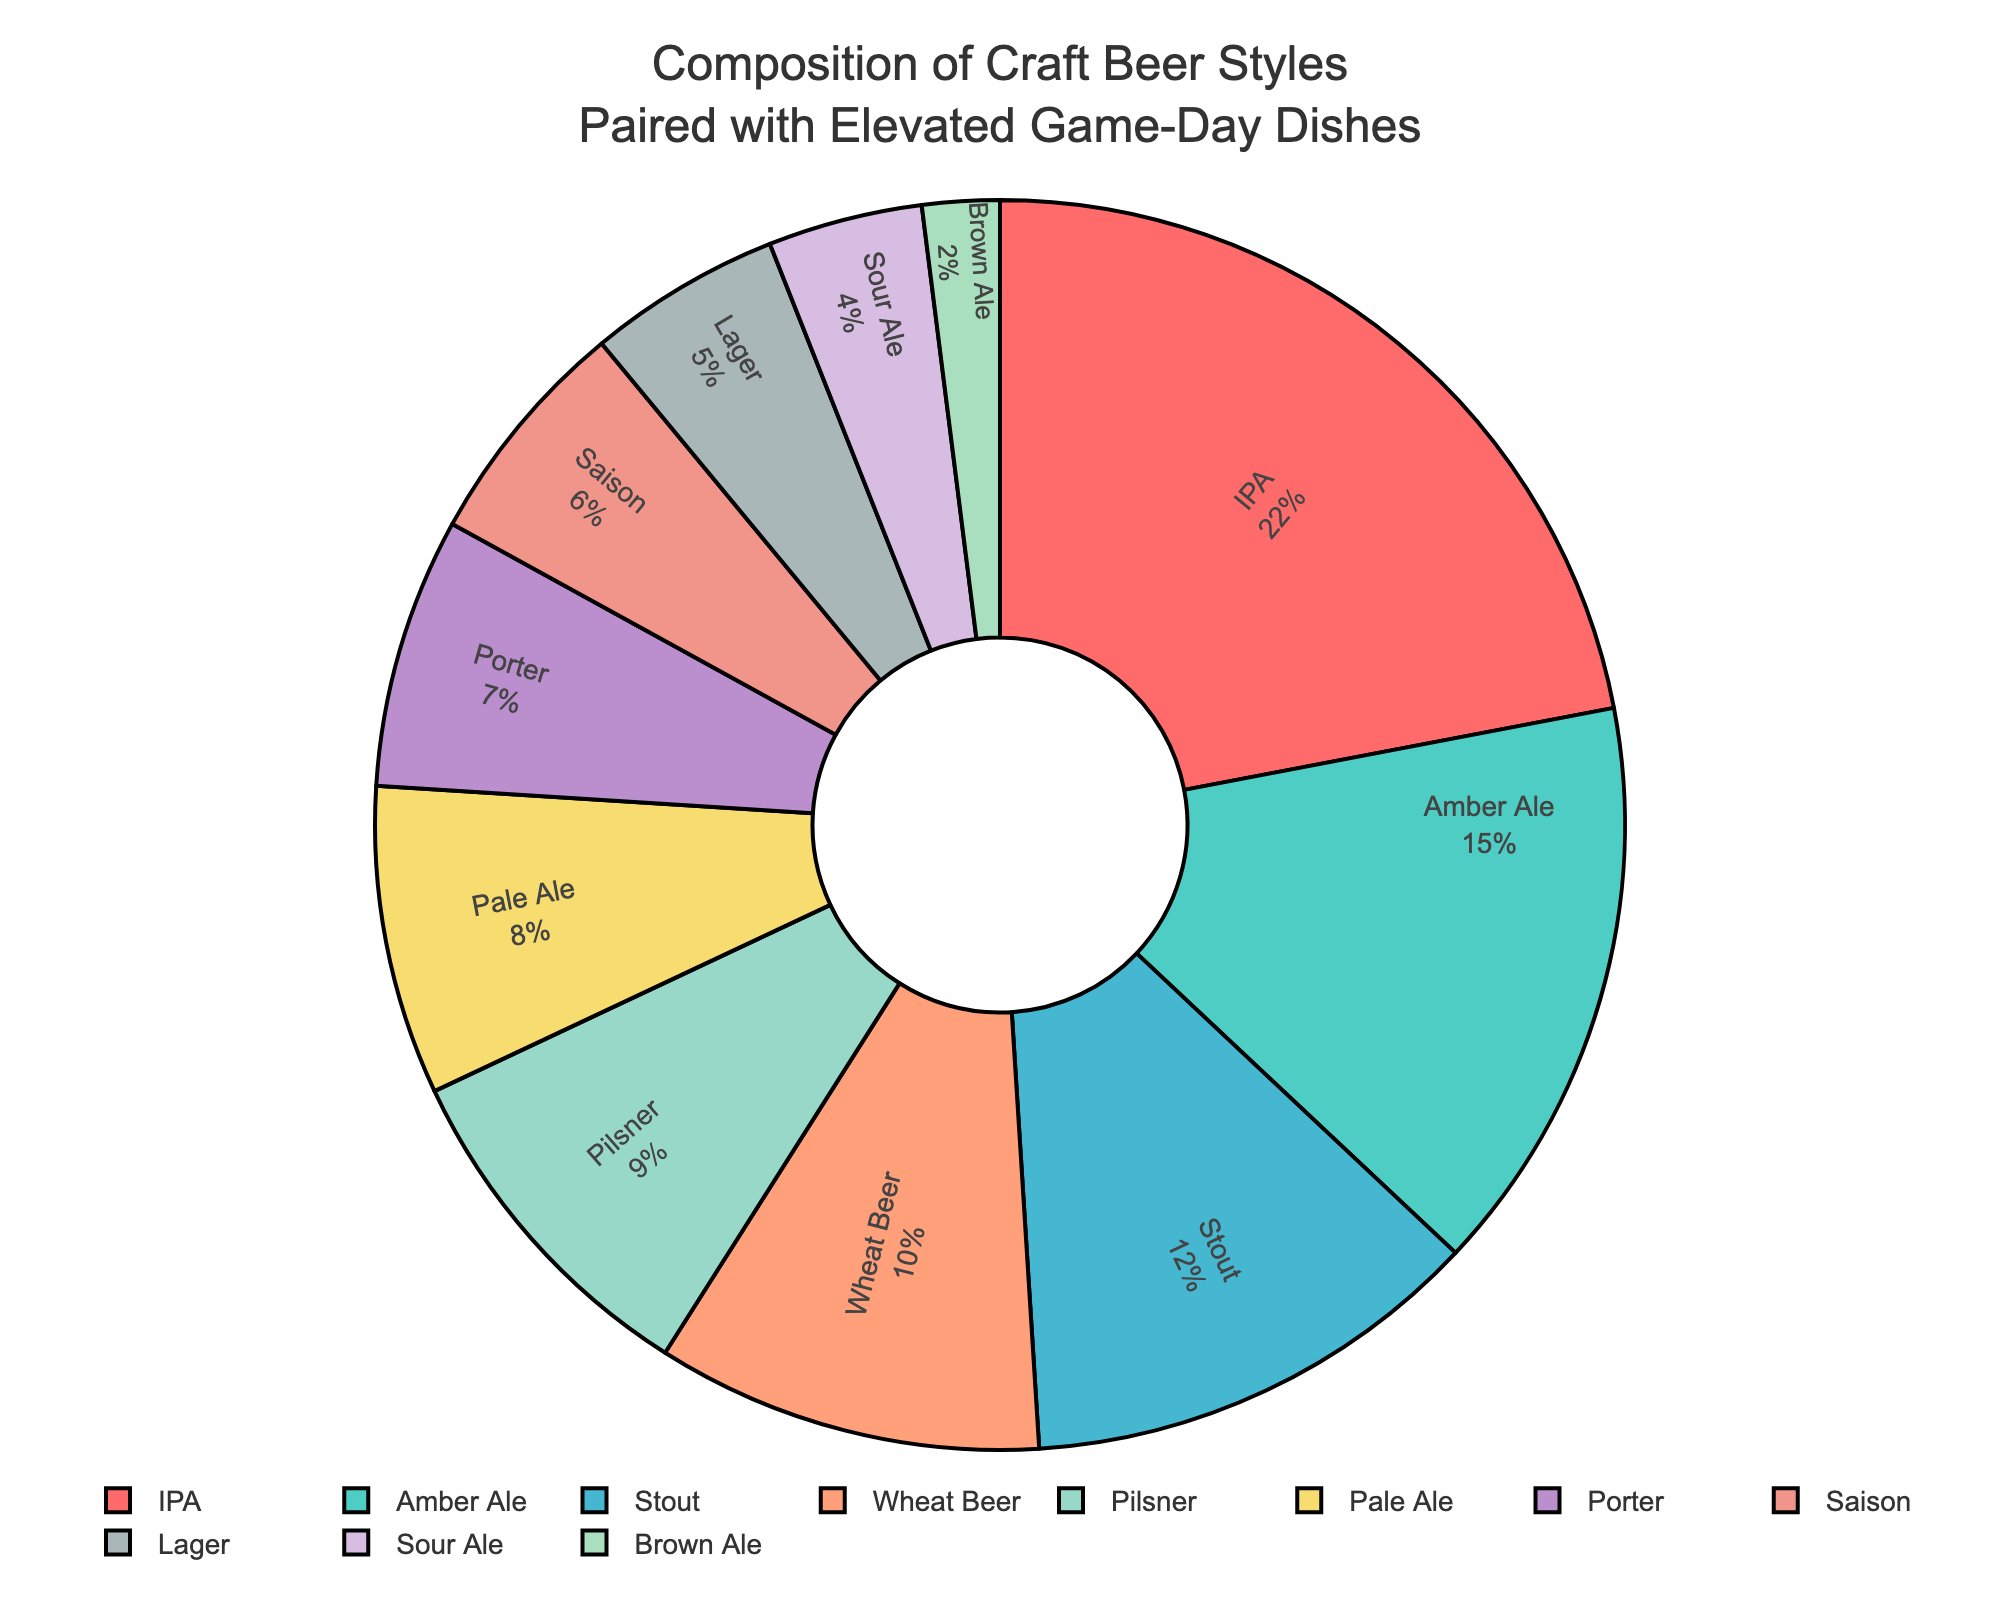Which beer style has the highest percentage? By observing the labels inside the pie segments, the label with the highest percentage value should be identified.
Answer: IPA Which beer style has a higher percentage, Saison or Pilsner? Look at the percentages for both Saison and Pilsner from the chart, then compare their values. Saison is 6% and Pilsner is 9%.
Answer: Pilsner What is the combined percentage of Amber Ale and Stout? Locate Amber Ale and Stout in the chart and add their percentages: 15% (Amber Ale) + 12% (Stout).
Answer: 27% Which beer styles have a percentage less than Lager? Identify the percentage for Lager (5%) and then determine which beer styles have percentages less than this value (Sour Ale with 4%, and Brown Ale with 2%).
Answer: Sour Ale and Brown Ale How does the percentage of Wheat Beer compare to that of Pale Ale? Find the percentages for Wheat Beer (10%) and Pale Ale (8%) from the chart. Wheat Beer is larger.
Answer: Wheat Beer > Pale Ale What is the difference in percentage between the highest and the lowest represented beer styles? Identify the highest (IPA with 22%) and the lowest (Brown Ale with 2%) percentages and subtract the smallest from the largest: 22% - 2%.
Answer: 20% Which two beer styles together make up more than half of the total percentage? By combining top beer styles and checking their sum: IPA (22%) + Amber Ale (15%) + Stout (12%) = 49%, need one more percentage, so IPA (22%) + Amber Ale (15%) + Wheat Beer (10%) = 47%. Thus, IPA (22%) + Amber Ale (15%) + Wheat Beer (10%) + Pilsner (9%) = 56% which is over half.
Answer: IPA and Amber Ale with any one more Which beer styles are represented with colors visually described as warm (like orange or red)? Identify the beer styles shaded with warm colors by observing the pie chart's color distribution (IPA is likely red, and Wheat Beer is likely peachy based on natural descriptions).
Answer: IPA and Wheat Beer 